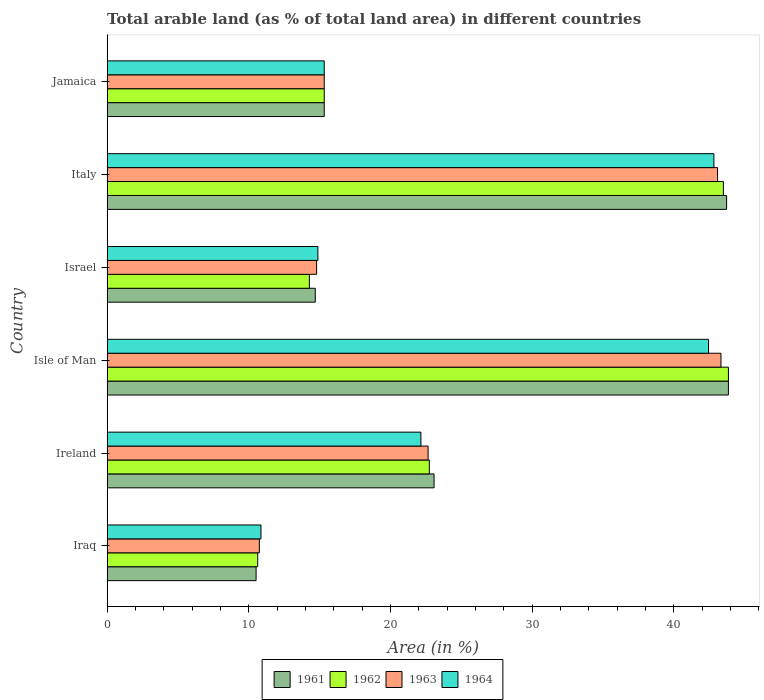How many different coloured bars are there?
Provide a short and direct response. 4. Are the number of bars on each tick of the Y-axis equal?
Ensure brevity in your answer.  Yes. How many bars are there on the 3rd tick from the top?
Make the answer very short. 4. What is the label of the 5th group of bars from the top?
Offer a terse response. Ireland. What is the percentage of arable land in 1961 in Israel?
Your answer should be very brief. 14.7. Across all countries, what is the maximum percentage of arable land in 1964?
Offer a terse response. 42.83. Across all countries, what is the minimum percentage of arable land in 1962?
Your response must be concise. 10.63. In which country was the percentage of arable land in 1962 maximum?
Offer a terse response. Isle of Man. In which country was the percentage of arable land in 1963 minimum?
Keep it short and to the point. Iraq. What is the total percentage of arable land in 1964 in the graph?
Offer a terse response. 148.51. What is the difference between the percentage of arable land in 1962 in Ireland and that in Italy?
Keep it short and to the point. -20.76. What is the difference between the percentage of arable land in 1962 in Ireland and the percentage of arable land in 1961 in Italy?
Provide a succinct answer. -20.99. What is the average percentage of arable land in 1961 per country?
Give a very brief answer. 25.2. What is the difference between the percentage of arable land in 1962 and percentage of arable land in 1961 in Israel?
Offer a terse response. -0.42. What is the ratio of the percentage of arable land in 1963 in Iraq to that in Israel?
Offer a terse response. 0.73. What is the difference between the highest and the second highest percentage of arable land in 1963?
Your response must be concise. 0.24. What is the difference between the highest and the lowest percentage of arable land in 1963?
Give a very brief answer. 32.59. In how many countries, is the percentage of arable land in 1961 greater than the average percentage of arable land in 1961 taken over all countries?
Offer a terse response. 2. How many bars are there?
Your answer should be very brief. 24. Are all the bars in the graph horizontal?
Your answer should be compact. Yes. Are the values on the major ticks of X-axis written in scientific E-notation?
Offer a very short reply. No. Does the graph contain grids?
Give a very brief answer. No. How are the legend labels stacked?
Ensure brevity in your answer.  Horizontal. What is the title of the graph?
Your answer should be compact. Total arable land (as % of total land area) in different countries. What is the label or title of the X-axis?
Provide a succinct answer. Area (in %). What is the label or title of the Y-axis?
Keep it short and to the point. Country. What is the Area (in %) of 1961 in Iraq?
Your answer should be compact. 10.52. What is the Area (in %) in 1962 in Iraq?
Offer a terse response. 10.63. What is the Area (in %) in 1963 in Iraq?
Keep it short and to the point. 10.75. What is the Area (in %) in 1964 in Iraq?
Offer a very short reply. 10.86. What is the Area (in %) in 1961 in Ireland?
Offer a very short reply. 23.08. What is the Area (in %) of 1962 in Ireland?
Offer a very short reply. 22.75. What is the Area (in %) of 1963 in Ireland?
Give a very brief answer. 22.66. What is the Area (in %) of 1964 in Ireland?
Offer a terse response. 22.15. What is the Area (in %) of 1961 in Isle of Man?
Provide a succinct answer. 43.86. What is the Area (in %) of 1962 in Isle of Man?
Provide a short and direct response. 43.86. What is the Area (in %) of 1963 in Isle of Man?
Offer a very short reply. 43.33. What is the Area (in %) of 1964 in Isle of Man?
Offer a terse response. 42.46. What is the Area (in %) of 1961 in Israel?
Your response must be concise. 14.7. What is the Area (in %) in 1962 in Israel?
Ensure brevity in your answer.  14.28. What is the Area (in %) of 1963 in Israel?
Offer a terse response. 14.79. What is the Area (in %) of 1964 in Israel?
Your answer should be very brief. 14.88. What is the Area (in %) of 1961 in Italy?
Offer a terse response. 43.73. What is the Area (in %) of 1962 in Italy?
Make the answer very short. 43.5. What is the Area (in %) of 1963 in Italy?
Offer a very short reply. 43.09. What is the Area (in %) in 1964 in Italy?
Your answer should be very brief. 42.83. What is the Area (in %) in 1961 in Jamaica?
Make the answer very short. 15.33. What is the Area (in %) of 1962 in Jamaica?
Keep it short and to the point. 15.33. What is the Area (in %) in 1963 in Jamaica?
Ensure brevity in your answer.  15.33. What is the Area (in %) in 1964 in Jamaica?
Offer a terse response. 15.33. Across all countries, what is the maximum Area (in %) of 1961?
Your answer should be very brief. 43.86. Across all countries, what is the maximum Area (in %) in 1962?
Keep it short and to the point. 43.86. Across all countries, what is the maximum Area (in %) in 1963?
Provide a short and direct response. 43.33. Across all countries, what is the maximum Area (in %) of 1964?
Ensure brevity in your answer.  42.83. Across all countries, what is the minimum Area (in %) in 1961?
Your answer should be compact. 10.52. Across all countries, what is the minimum Area (in %) in 1962?
Offer a terse response. 10.63. Across all countries, what is the minimum Area (in %) of 1963?
Give a very brief answer. 10.75. Across all countries, what is the minimum Area (in %) of 1964?
Your answer should be very brief. 10.86. What is the total Area (in %) of 1961 in the graph?
Make the answer very short. 151.21. What is the total Area (in %) in 1962 in the graph?
Offer a terse response. 150.35. What is the total Area (in %) of 1963 in the graph?
Offer a very short reply. 149.95. What is the total Area (in %) of 1964 in the graph?
Provide a short and direct response. 148.51. What is the difference between the Area (in %) of 1961 in Iraq and that in Ireland?
Ensure brevity in your answer.  -12.56. What is the difference between the Area (in %) in 1962 in Iraq and that in Ireland?
Ensure brevity in your answer.  -12.11. What is the difference between the Area (in %) of 1963 in Iraq and that in Ireland?
Ensure brevity in your answer.  -11.91. What is the difference between the Area (in %) of 1964 in Iraq and that in Ireland?
Offer a very short reply. -11.29. What is the difference between the Area (in %) of 1961 in Iraq and that in Isle of Man?
Keep it short and to the point. -33.34. What is the difference between the Area (in %) in 1962 in Iraq and that in Isle of Man?
Ensure brevity in your answer.  -33.23. What is the difference between the Area (in %) of 1963 in Iraq and that in Isle of Man?
Your answer should be very brief. -32.59. What is the difference between the Area (in %) in 1964 in Iraq and that in Isle of Man?
Offer a terse response. -31.6. What is the difference between the Area (in %) in 1961 in Iraq and that in Israel?
Your answer should be very brief. -4.18. What is the difference between the Area (in %) of 1962 in Iraq and that in Israel?
Make the answer very short. -3.65. What is the difference between the Area (in %) of 1963 in Iraq and that in Israel?
Your answer should be compact. -4.04. What is the difference between the Area (in %) of 1964 in Iraq and that in Israel?
Your response must be concise. -4.02. What is the difference between the Area (in %) of 1961 in Iraq and that in Italy?
Provide a succinct answer. -33.21. What is the difference between the Area (in %) in 1962 in Iraq and that in Italy?
Your answer should be compact. -32.87. What is the difference between the Area (in %) in 1963 in Iraq and that in Italy?
Offer a terse response. -32.35. What is the difference between the Area (in %) of 1964 in Iraq and that in Italy?
Make the answer very short. -31.97. What is the difference between the Area (in %) in 1961 in Iraq and that in Jamaica?
Your answer should be very brief. -4.81. What is the difference between the Area (in %) of 1962 in Iraq and that in Jamaica?
Ensure brevity in your answer.  -4.7. What is the difference between the Area (in %) of 1963 in Iraq and that in Jamaica?
Make the answer very short. -4.58. What is the difference between the Area (in %) in 1964 in Iraq and that in Jamaica?
Offer a terse response. -4.47. What is the difference between the Area (in %) in 1961 in Ireland and that in Isle of Man?
Offer a very short reply. -20.78. What is the difference between the Area (in %) in 1962 in Ireland and that in Isle of Man?
Your response must be concise. -21.11. What is the difference between the Area (in %) in 1963 in Ireland and that in Isle of Man?
Ensure brevity in your answer.  -20.67. What is the difference between the Area (in %) of 1964 in Ireland and that in Isle of Man?
Ensure brevity in your answer.  -20.3. What is the difference between the Area (in %) of 1961 in Ireland and that in Israel?
Your answer should be compact. 8.39. What is the difference between the Area (in %) of 1962 in Ireland and that in Israel?
Provide a succinct answer. 8.47. What is the difference between the Area (in %) in 1963 in Ireland and that in Israel?
Ensure brevity in your answer.  7.87. What is the difference between the Area (in %) in 1964 in Ireland and that in Israel?
Make the answer very short. 7.27. What is the difference between the Area (in %) in 1961 in Ireland and that in Italy?
Offer a terse response. -20.65. What is the difference between the Area (in %) of 1962 in Ireland and that in Italy?
Your answer should be compact. -20.76. What is the difference between the Area (in %) in 1963 in Ireland and that in Italy?
Offer a terse response. -20.43. What is the difference between the Area (in %) of 1964 in Ireland and that in Italy?
Your response must be concise. -20.68. What is the difference between the Area (in %) of 1961 in Ireland and that in Jamaica?
Your answer should be very brief. 7.75. What is the difference between the Area (in %) of 1962 in Ireland and that in Jamaica?
Provide a succinct answer. 7.42. What is the difference between the Area (in %) in 1963 in Ireland and that in Jamaica?
Offer a terse response. 7.33. What is the difference between the Area (in %) of 1964 in Ireland and that in Jamaica?
Your answer should be very brief. 6.82. What is the difference between the Area (in %) of 1961 in Isle of Man and that in Israel?
Provide a short and direct response. 29.16. What is the difference between the Area (in %) of 1962 in Isle of Man and that in Israel?
Your answer should be compact. 29.58. What is the difference between the Area (in %) in 1963 in Isle of Man and that in Israel?
Your response must be concise. 28.55. What is the difference between the Area (in %) of 1964 in Isle of Man and that in Israel?
Offer a very short reply. 27.58. What is the difference between the Area (in %) of 1961 in Isle of Man and that in Italy?
Provide a succinct answer. 0.13. What is the difference between the Area (in %) of 1962 in Isle of Man and that in Italy?
Provide a succinct answer. 0.36. What is the difference between the Area (in %) in 1963 in Isle of Man and that in Italy?
Provide a succinct answer. 0.24. What is the difference between the Area (in %) of 1964 in Isle of Man and that in Italy?
Offer a very short reply. -0.38. What is the difference between the Area (in %) of 1961 in Isle of Man and that in Jamaica?
Your answer should be compact. 28.53. What is the difference between the Area (in %) in 1962 in Isle of Man and that in Jamaica?
Offer a very short reply. 28.53. What is the difference between the Area (in %) of 1963 in Isle of Man and that in Jamaica?
Offer a very short reply. 28.01. What is the difference between the Area (in %) of 1964 in Isle of Man and that in Jamaica?
Keep it short and to the point. 27.13. What is the difference between the Area (in %) of 1961 in Israel and that in Italy?
Keep it short and to the point. -29.04. What is the difference between the Area (in %) in 1962 in Israel and that in Italy?
Provide a succinct answer. -29.23. What is the difference between the Area (in %) of 1963 in Israel and that in Italy?
Your answer should be compact. -28.31. What is the difference between the Area (in %) in 1964 in Israel and that in Italy?
Give a very brief answer. -27.95. What is the difference between the Area (in %) of 1961 in Israel and that in Jamaica?
Offer a very short reply. -0.63. What is the difference between the Area (in %) of 1962 in Israel and that in Jamaica?
Keep it short and to the point. -1.05. What is the difference between the Area (in %) of 1963 in Israel and that in Jamaica?
Ensure brevity in your answer.  -0.54. What is the difference between the Area (in %) in 1964 in Israel and that in Jamaica?
Offer a very short reply. -0.45. What is the difference between the Area (in %) in 1961 in Italy and that in Jamaica?
Your response must be concise. 28.4. What is the difference between the Area (in %) of 1962 in Italy and that in Jamaica?
Provide a short and direct response. 28.18. What is the difference between the Area (in %) of 1963 in Italy and that in Jamaica?
Your answer should be very brief. 27.76. What is the difference between the Area (in %) in 1964 in Italy and that in Jamaica?
Provide a succinct answer. 27.51. What is the difference between the Area (in %) of 1961 in Iraq and the Area (in %) of 1962 in Ireland?
Make the answer very short. -12.23. What is the difference between the Area (in %) in 1961 in Iraq and the Area (in %) in 1963 in Ireland?
Offer a very short reply. -12.14. What is the difference between the Area (in %) of 1961 in Iraq and the Area (in %) of 1964 in Ireland?
Your response must be concise. -11.63. What is the difference between the Area (in %) of 1962 in Iraq and the Area (in %) of 1963 in Ireland?
Your response must be concise. -12.03. What is the difference between the Area (in %) in 1962 in Iraq and the Area (in %) in 1964 in Ireland?
Make the answer very short. -11.52. What is the difference between the Area (in %) of 1963 in Iraq and the Area (in %) of 1964 in Ireland?
Keep it short and to the point. -11.41. What is the difference between the Area (in %) of 1961 in Iraq and the Area (in %) of 1962 in Isle of Man?
Ensure brevity in your answer.  -33.34. What is the difference between the Area (in %) of 1961 in Iraq and the Area (in %) of 1963 in Isle of Man?
Keep it short and to the point. -32.82. What is the difference between the Area (in %) in 1961 in Iraq and the Area (in %) in 1964 in Isle of Man?
Give a very brief answer. -31.94. What is the difference between the Area (in %) in 1962 in Iraq and the Area (in %) in 1963 in Isle of Man?
Your answer should be compact. -32.7. What is the difference between the Area (in %) in 1962 in Iraq and the Area (in %) in 1964 in Isle of Man?
Provide a succinct answer. -31.82. What is the difference between the Area (in %) in 1963 in Iraq and the Area (in %) in 1964 in Isle of Man?
Make the answer very short. -31.71. What is the difference between the Area (in %) of 1961 in Iraq and the Area (in %) of 1962 in Israel?
Provide a short and direct response. -3.76. What is the difference between the Area (in %) of 1961 in Iraq and the Area (in %) of 1963 in Israel?
Keep it short and to the point. -4.27. What is the difference between the Area (in %) in 1961 in Iraq and the Area (in %) in 1964 in Israel?
Give a very brief answer. -4.36. What is the difference between the Area (in %) of 1962 in Iraq and the Area (in %) of 1963 in Israel?
Offer a terse response. -4.16. What is the difference between the Area (in %) of 1962 in Iraq and the Area (in %) of 1964 in Israel?
Your answer should be compact. -4.25. What is the difference between the Area (in %) of 1963 in Iraq and the Area (in %) of 1964 in Israel?
Your answer should be compact. -4.13. What is the difference between the Area (in %) in 1961 in Iraq and the Area (in %) in 1962 in Italy?
Keep it short and to the point. -32.99. What is the difference between the Area (in %) in 1961 in Iraq and the Area (in %) in 1963 in Italy?
Make the answer very short. -32.58. What is the difference between the Area (in %) of 1961 in Iraq and the Area (in %) of 1964 in Italy?
Make the answer very short. -32.32. What is the difference between the Area (in %) in 1962 in Iraq and the Area (in %) in 1963 in Italy?
Give a very brief answer. -32.46. What is the difference between the Area (in %) in 1962 in Iraq and the Area (in %) in 1964 in Italy?
Make the answer very short. -32.2. What is the difference between the Area (in %) of 1963 in Iraq and the Area (in %) of 1964 in Italy?
Provide a succinct answer. -32.09. What is the difference between the Area (in %) of 1961 in Iraq and the Area (in %) of 1962 in Jamaica?
Offer a very short reply. -4.81. What is the difference between the Area (in %) of 1961 in Iraq and the Area (in %) of 1963 in Jamaica?
Your answer should be very brief. -4.81. What is the difference between the Area (in %) of 1961 in Iraq and the Area (in %) of 1964 in Jamaica?
Make the answer very short. -4.81. What is the difference between the Area (in %) of 1962 in Iraq and the Area (in %) of 1963 in Jamaica?
Make the answer very short. -4.7. What is the difference between the Area (in %) of 1962 in Iraq and the Area (in %) of 1964 in Jamaica?
Provide a short and direct response. -4.7. What is the difference between the Area (in %) in 1963 in Iraq and the Area (in %) in 1964 in Jamaica?
Your answer should be very brief. -4.58. What is the difference between the Area (in %) in 1961 in Ireland and the Area (in %) in 1962 in Isle of Man?
Offer a terse response. -20.78. What is the difference between the Area (in %) in 1961 in Ireland and the Area (in %) in 1963 in Isle of Man?
Provide a succinct answer. -20.25. What is the difference between the Area (in %) in 1961 in Ireland and the Area (in %) in 1964 in Isle of Man?
Provide a short and direct response. -19.38. What is the difference between the Area (in %) in 1962 in Ireland and the Area (in %) in 1963 in Isle of Man?
Your response must be concise. -20.59. What is the difference between the Area (in %) in 1962 in Ireland and the Area (in %) in 1964 in Isle of Man?
Make the answer very short. -19.71. What is the difference between the Area (in %) in 1963 in Ireland and the Area (in %) in 1964 in Isle of Man?
Ensure brevity in your answer.  -19.8. What is the difference between the Area (in %) in 1961 in Ireland and the Area (in %) in 1962 in Israel?
Provide a succinct answer. 8.8. What is the difference between the Area (in %) in 1961 in Ireland and the Area (in %) in 1963 in Israel?
Give a very brief answer. 8.29. What is the difference between the Area (in %) of 1961 in Ireland and the Area (in %) of 1964 in Israel?
Your answer should be very brief. 8.2. What is the difference between the Area (in %) in 1962 in Ireland and the Area (in %) in 1963 in Israel?
Make the answer very short. 7.96. What is the difference between the Area (in %) in 1962 in Ireland and the Area (in %) in 1964 in Israel?
Your response must be concise. 7.87. What is the difference between the Area (in %) in 1963 in Ireland and the Area (in %) in 1964 in Israel?
Provide a short and direct response. 7.78. What is the difference between the Area (in %) of 1961 in Ireland and the Area (in %) of 1962 in Italy?
Provide a short and direct response. -20.42. What is the difference between the Area (in %) in 1961 in Ireland and the Area (in %) in 1963 in Italy?
Your response must be concise. -20.01. What is the difference between the Area (in %) in 1961 in Ireland and the Area (in %) in 1964 in Italy?
Make the answer very short. -19.75. What is the difference between the Area (in %) in 1962 in Ireland and the Area (in %) in 1963 in Italy?
Your response must be concise. -20.35. What is the difference between the Area (in %) of 1962 in Ireland and the Area (in %) of 1964 in Italy?
Make the answer very short. -20.09. What is the difference between the Area (in %) in 1963 in Ireland and the Area (in %) in 1964 in Italy?
Provide a short and direct response. -20.18. What is the difference between the Area (in %) in 1961 in Ireland and the Area (in %) in 1962 in Jamaica?
Ensure brevity in your answer.  7.75. What is the difference between the Area (in %) in 1961 in Ireland and the Area (in %) in 1963 in Jamaica?
Your answer should be compact. 7.75. What is the difference between the Area (in %) of 1961 in Ireland and the Area (in %) of 1964 in Jamaica?
Your answer should be very brief. 7.75. What is the difference between the Area (in %) in 1962 in Ireland and the Area (in %) in 1963 in Jamaica?
Your response must be concise. 7.42. What is the difference between the Area (in %) in 1962 in Ireland and the Area (in %) in 1964 in Jamaica?
Your answer should be very brief. 7.42. What is the difference between the Area (in %) of 1963 in Ireland and the Area (in %) of 1964 in Jamaica?
Offer a terse response. 7.33. What is the difference between the Area (in %) of 1961 in Isle of Man and the Area (in %) of 1962 in Israel?
Your answer should be compact. 29.58. What is the difference between the Area (in %) in 1961 in Isle of Man and the Area (in %) in 1963 in Israel?
Offer a terse response. 29.07. What is the difference between the Area (in %) of 1961 in Isle of Man and the Area (in %) of 1964 in Israel?
Give a very brief answer. 28.98. What is the difference between the Area (in %) of 1962 in Isle of Man and the Area (in %) of 1963 in Israel?
Your response must be concise. 29.07. What is the difference between the Area (in %) of 1962 in Isle of Man and the Area (in %) of 1964 in Israel?
Give a very brief answer. 28.98. What is the difference between the Area (in %) in 1963 in Isle of Man and the Area (in %) in 1964 in Israel?
Offer a terse response. 28.45. What is the difference between the Area (in %) of 1961 in Isle of Man and the Area (in %) of 1962 in Italy?
Your answer should be compact. 0.36. What is the difference between the Area (in %) in 1961 in Isle of Man and the Area (in %) in 1963 in Italy?
Make the answer very short. 0.77. What is the difference between the Area (in %) in 1961 in Isle of Man and the Area (in %) in 1964 in Italy?
Give a very brief answer. 1.03. What is the difference between the Area (in %) of 1962 in Isle of Man and the Area (in %) of 1963 in Italy?
Offer a very short reply. 0.77. What is the difference between the Area (in %) of 1962 in Isle of Man and the Area (in %) of 1964 in Italy?
Your answer should be very brief. 1.03. What is the difference between the Area (in %) in 1963 in Isle of Man and the Area (in %) in 1964 in Italy?
Your answer should be very brief. 0.5. What is the difference between the Area (in %) in 1961 in Isle of Man and the Area (in %) in 1962 in Jamaica?
Ensure brevity in your answer.  28.53. What is the difference between the Area (in %) in 1961 in Isle of Man and the Area (in %) in 1963 in Jamaica?
Keep it short and to the point. 28.53. What is the difference between the Area (in %) of 1961 in Isle of Man and the Area (in %) of 1964 in Jamaica?
Keep it short and to the point. 28.53. What is the difference between the Area (in %) in 1962 in Isle of Man and the Area (in %) in 1963 in Jamaica?
Make the answer very short. 28.53. What is the difference between the Area (in %) in 1962 in Isle of Man and the Area (in %) in 1964 in Jamaica?
Offer a very short reply. 28.53. What is the difference between the Area (in %) of 1963 in Isle of Man and the Area (in %) of 1964 in Jamaica?
Your answer should be compact. 28.01. What is the difference between the Area (in %) in 1961 in Israel and the Area (in %) in 1962 in Italy?
Your answer should be compact. -28.81. What is the difference between the Area (in %) in 1961 in Israel and the Area (in %) in 1963 in Italy?
Ensure brevity in your answer.  -28.4. What is the difference between the Area (in %) of 1961 in Israel and the Area (in %) of 1964 in Italy?
Keep it short and to the point. -28.14. What is the difference between the Area (in %) in 1962 in Israel and the Area (in %) in 1963 in Italy?
Offer a terse response. -28.81. What is the difference between the Area (in %) in 1962 in Israel and the Area (in %) in 1964 in Italy?
Ensure brevity in your answer.  -28.56. What is the difference between the Area (in %) in 1963 in Israel and the Area (in %) in 1964 in Italy?
Ensure brevity in your answer.  -28.05. What is the difference between the Area (in %) of 1961 in Israel and the Area (in %) of 1962 in Jamaica?
Keep it short and to the point. -0.63. What is the difference between the Area (in %) of 1961 in Israel and the Area (in %) of 1963 in Jamaica?
Your response must be concise. -0.63. What is the difference between the Area (in %) in 1961 in Israel and the Area (in %) in 1964 in Jamaica?
Offer a very short reply. -0.63. What is the difference between the Area (in %) of 1962 in Israel and the Area (in %) of 1963 in Jamaica?
Your answer should be compact. -1.05. What is the difference between the Area (in %) in 1962 in Israel and the Area (in %) in 1964 in Jamaica?
Make the answer very short. -1.05. What is the difference between the Area (in %) in 1963 in Israel and the Area (in %) in 1964 in Jamaica?
Offer a very short reply. -0.54. What is the difference between the Area (in %) in 1961 in Italy and the Area (in %) in 1962 in Jamaica?
Your answer should be compact. 28.4. What is the difference between the Area (in %) of 1961 in Italy and the Area (in %) of 1963 in Jamaica?
Your answer should be very brief. 28.4. What is the difference between the Area (in %) of 1961 in Italy and the Area (in %) of 1964 in Jamaica?
Make the answer very short. 28.4. What is the difference between the Area (in %) in 1962 in Italy and the Area (in %) in 1963 in Jamaica?
Provide a succinct answer. 28.18. What is the difference between the Area (in %) of 1962 in Italy and the Area (in %) of 1964 in Jamaica?
Your answer should be very brief. 28.18. What is the difference between the Area (in %) of 1963 in Italy and the Area (in %) of 1964 in Jamaica?
Ensure brevity in your answer.  27.76. What is the average Area (in %) of 1961 per country?
Give a very brief answer. 25.2. What is the average Area (in %) of 1962 per country?
Make the answer very short. 25.06. What is the average Area (in %) of 1963 per country?
Your answer should be compact. 24.99. What is the average Area (in %) in 1964 per country?
Offer a terse response. 24.75. What is the difference between the Area (in %) of 1961 and Area (in %) of 1962 in Iraq?
Keep it short and to the point. -0.11. What is the difference between the Area (in %) of 1961 and Area (in %) of 1963 in Iraq?
Your response must be concise. -0.23. What is the difference between the Area (in %) in 1961 and Area (in %) in 1964 in Iraq?
Your answer should be compact. -0.34. What is the difference between the Area (in %) in 1962 and Area (in %) in 1963 in Iraq?
Offer a very short reply. -0.11. What is the difference between the Area (in %) of 1962 and Area (in %) of 1964 in Iraq?
Provide a succinct answer. -0.23. What is the difference between the Area (in %) of 1963 and Area (in %) of 1964 in Iraq?
Make the answer very short. -0.11. What is the difference between the Area (in %) of 1961 and Area (in %) of 1962 in Ireland?
Your answer should be very brief. 0.33. What is the difference between the Area (in %) of 1961 and Area (in %) of 1963 in Ireland?
Keep it short and to the point. 0.42. What is the difference between the Area (in %) of 1961 and Area (in %) of 1964 in Ireland?
Your response must be concise. 0.93. What is the difference between the Area (in %) in 1962 and Area (in %) in 1963 in Ireland?
Your response must be concise. 0.09. What is the difference between the Area (in %) of 1962 and Area (in %) of 1964 in Ireland?
Make the answer very short. 0.6. What is the difference between the Area (in %) in 1963 and Area (in %) in 1964 in Ireland?
Offer a very short reply. 0.51. What is the difference between the Area (in %) in 1961 and Area (in %) in 1962 in Isle of Man?
Provide a succinct answer. 0. What is the difference between the Area (in %) of 1961 and Area (in %) of 1963 in Isle of Man?
Provide a succinct answer. 0.53. What is the difference between the Area (in %) in 1961 and Area (in %) in 1964 in Isle of Man?
Keep it short and to the point. 1.4. What is the difference between the Area (in %) in 1962 and Area (in %) in 1963 in Isle of Man?
Your response must be concise. 0.53. What is the difference between the Area (in %) in 1962 and Area (in %) in 1964 in Isle of Man?
Your answer should be very brief. 1.4. What is the difference between the Area (in %) in 1963 and Area (in %) in 1964 in Isle of Man?
Give a very brief answer. 0.88. What is the difference between the Area (in %) in 1961 and Area (in %) in 1962 in Israel?
Provide a short and direct response. 0.42. What is the difference between the Area (in %) in 1961 and Area (in %) in 1963 in Israel?
Ensure brevity in your answer.  -0.09. What is the difference between the Area (in %) of 1961 and Area (in %) of 1964 in Israel?
Your answer should be compact. -0.18. What is the difference between the Area (in %) of 1962 and Area (in %) of 1963 in Israel?
Provide a short and direct response. -0.51. What is the difference between the Area (in %) of 1962 and Area (in %) of 1964 in Israel?
Your response must be concise. -0.6. What is the difference between the Area (in %) of 1963 and Area (in %) of 1964 in Israel?
Your answer should be compact. -0.09. What is the difference between the Area (in %) in 1961 and Area (in %) in 1962 in Italy?
Your response must be concise. 0.23. What is the difference between the Area (in %) in 1961 and Area (in %) in 1963 in Italy?
Make the answer very short. 0.64. What is the difference between the Area (in %) in 1961 and Area (in %) in 1964 in Italy?
Your answer should be compact. 0.9. What is the difference between the Area (in %) in 1962 and Area (in %) in 1963 in Italy?
Your answer should be very brief. 0.41. What is the difference between the Area (in %) of 1962 and Area (in %) of 1964 in Italy?
Your answer should be compact. 0.67. What is the difference between the Area (in %) in 1963 and Area (in %) in 1964 in Italy?
Ensure brevity in your answer.  0.26. What is the difference between the Area (in %) in 1961 and Area (in %) in 1962 in Jamaica?
Your response must be concise. 0. What is the difference between the Area (in %) in 1961 and Area (in %) in 1963 in Jamaica?
Offer a very short reply. 0. What is the difference between the Area (in %) in 1962 and Area (in %) in 1963 in Jamaica?
Keep it short and to the point. 0. What is the difference between the Area (in %) of 1962 and Area (in %) of 1964 in Jamaica?
Give a very brief answer. 0. What is the difference between the Area (in %) of 1963 and Area (in %) of 1964 in Jamaica?
Ensure brevity in your answer.  0. What is the ratio of the Area (in %) in 1961 in Iraq to that in Ireland?
Your response must be concise. 0.46. What is the ratio of the Area (in %) in 1962 in Iraq to that in Ireland?
Ensure brevity in your answer.  0.47. What is the ratio of the Area (in %) in 1963 in Iraq to that in Ireland?
Your answer should be compact. 0.47. What is the ratio of the Area (in %) of 1964 in Iraq to that in Ireland?
Give a very brief answer. 0.49. What is the ratio of the Area (in %) in 1961 in Iraq to that in Isle of Man?
Make the answer very short. 0.24. What is the ratio of the Area (in %) in 1962 in Iraq to that in Isle of Man?
Provide a short and direct response. 0.24. What is the ratio of the Area (in %) of 1963 in Iraq to that in Isle of Man?
Your response must be concise. 0.25. What is the ratio of the Area (in %) in 1964 in Iraq to that in Isle of Man?
Make the answer very short. 0.26. What is the ratio of the Area (in %) in 1961 in Iraq to that in Israel?
Your answer should be compact. 0.72. What is the ratio of the Area (in %) in 1962 in Iraq to that in Israel?
Your answer should be very brief. 0.74. What is the ratio of the Area (in %) of 1963 in Iraq to that in Israel?
Give a very brief answer. 0.73. What is the ratio of the Area (in %) of 1964 in Iraq to that in Israel?
Your answer should be compact. 0.73. What is the ratio of the Area (in %) of 1961 in Iraq to that in Italy?
Offer a very short reply. 0.24. What is the ratio of the Area (in %) of 1962 in Iraq to that in Italy?
Provide a short and direct response. 0.24. What is the ratio of the Area (in %) of 1963 in Iraq to that in Italy?
Make the answer very short. 0.25. What is the ratio of the Area (in %) of 1964 in Iraq to that in Italy?
Provide a succinct answer. 0.25. What is the ratio of the Area (in %) of 1961 in Iraq to that in Jamaica?
Ensure brevity in your answer.  0.69. What is the ratio of the Area (in %) of 1962 in Iraq to that in Jamaica?
Provide a short and direct response. 0.69. What is the ratio of the Area (in %) in 1963 in Iraq to that in Jamaica?
Ensure brevity in your answer.  0.7. What is the ratio of the Area (in %) in 1964 in Iraq to that in Jamaica?
Give a very brief answer. 0.71. What is the ratio of the Area (in %) of 1961 in Ireland to that in Isle of Man?
Your response must be concise. 0.53. What is the ratio of the Area (in %) in 1962 in Ireland to that in Isle of Man?
Offer a terse response. 0.52. What is the ratio of the Area (in %) in 1963 in Ireland to that in Isle of Man?
Keep it short and to the point. 0.52. What is the ratio of the Area (in %) in 1964 in Ireland to that in Isle of Man?
Your response must be concise. 0.52. What is the ratio of the Area (in %) in 1961 in Ireland to that in Israel?
Offer a terse response. 1.57. What is the ratio of the Area (in %) in 1962 in Ireland to that in Israel?
Make the answer very short. 1.59. What is the ratio of the Area (in %) in 1963 in Ireland to that in Israel?
Your answer should be compact. 1.53. What is the ratio of the Area (in %) in 1964 in Ireland to that in Israel?
Make the answer very short. 1.49. What is the ratio of the Area (in %) in 1961 in Ireland to that in Italy?
Make the answer very short. 0.53. What is the ratio of the Area (in %) of 1962 in Ireland to that in Italy?
Your response must be concise. 0.52. What is the ratio of the Area (in %) of 1963 in Ireland to that in Italy?
Provide a succinct answer. 0.53. What is the ratio of the Area (in %) in 1964 in Ireland to that in Italy?
Provide a short and direct response. 0.52. What is the ratio of the Area (in %) in 1961 in Ireland to that in Jamaica?
Keep it short and to the point. 1.51. What is the ratio of the Area (in %) of 1962 in Ireland to that in Jamaica?
Provide a succinct answer. 1.48. What is the ratio of the Area (in %) of 1963 in Ireland to that in Jamaica?
Provide a succinct answer. 1.48. What is the ratio of the Area (in %) in 1964 in Ireland to that in Jamaica?
Your answer should be very brief. 1.45. What is the ratio of the Area (in %) in 1961 in Isle of Man to that in Israel?
Offer a very short reply. 2.98. What is the ratio of the Area (in %) in 1962 in Isle of Man to that in Israel?
Keep it short and to the point. 3.07. What is the ratio of the Area (in %) of 1963 in Isle of Man to that in Israel?
Provide a succinct answer. 2.93. What is the ratio of the Area (in %) of 1964 in Isle of Man to that in Israel?
Make the answer very short. 2.85. What is the ratio of the Area (in %) in 1961 in Isle of Man to that in Italy?
Make the answer very short. 1. What is the ratio of the Area (in %) in 1962 in Isle of Man to that in Italy?
Make the answer very short. 1.01. What is the ratio of the Area (in %) in 1963 in Isle of Man to that in Italy?
Give a very brief answer. 1.01. What is the ratio of the Area (in %) of 1961 in Isle of Man to that in Jamaica?
Your response must be concise. 2.86. What is the ratio of the Area (in %) of 1962 in Isle of Man to that in Jamaica?
Your answer should be very brief. 2.86. What is the ratio of the Area (in %) in 1963 in Isle of Man to that in Jamaica?
Keep it short and to the point. 2.83. What is the ratio of the Area (in %) of 1964 in Isle of Man to that in Jamaica?
Make the answer very short. 2.77. What is the ratio of the Area (in %) in 1961 in Israel to that in Italy?
Your answer should be compact. 0.34. What is the ratio of the Area (in %) in 1962 in Israel to that in Italy?
Your answer should be very brief. 0.33. What is the ratio of the Area (in %) of 1963 in Israel to that in Italy?
Provide a short and direct response. 0.34. What is the ratio of the Area (in %) of 1964 in Israel to that in Italy?
Provide a short and direct response. 0.35. What is the ratio of the Area (in %) of 1961 in Israel to that in Jamaica?
Keep it short and to the point. 0.96. What is the ratio of the Area (in %) in 1962 in Israel to that in Jamaica?
Ensure brevity in your answer.  0.93. What is the ratio of the Area (in %) in 1963 in Israel to that in Jamaica?
Offer a terse response. 0.96. What is the ratio of the Area (in %) of 1964 in Israel to that in Jamaica?
Your answer should be very brief. 0.97. What is the ratio of the Area (in %) of 1961 in Italy to that in Jamaica?
Keep it short and to the point. 2.85. What is the ratio of the Area (in %) in 1962 in Italy to that in Jamaica?
Your answer should be compact. 2.84. What is the ratio of the Area (in %) of 1963 in Italy to that in Jamaica?
Your response must be concise. 2.81. What is the ratio of the Area (in %) of 1964 in Italy to that in Jamaica?
Keep it short and to the point. 2.79. What is the difference between the highest and the second highest Area (in %) of 1961?
Make the answer very short. 0.13. What is the difference between the highest and the second highest Area (in %) in 1962?
Your answer should be very brief. 0.36. What is the difference between the highest and the second highest Area (in %) in 1963?
Make the answer very short. 0.24. What is the difference between the highest and the second highest Area (in %) of 1964?
Your answer should be very brief. 0.38. What is the difference between the highest and the lowest Area (in %) in 1961?
Offer a very short reply. 33.34. What is the difference between the highest and the lowest Area (in %) of 1962?
Your answer should be very brief. 33.23. What is the difference between the highest and the lowest Area (in %) of 1963?
Your answer should be compact. 32.59. What is the difference between the highest and the lowest Area (in %) in 1964?
Offer a terse response. 31.97. 